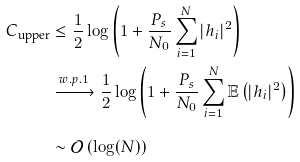Convert formula to latex. <formula><loc_0><loc_0><loc_500><loc_500>C _ { \text {upper} } & \leq \frac { 1 } { 2 } \log \left ( 1 + \frac { P _ { s } } { N _ { 0 } } \sum _ { i = 1 } ^ { N } | h _ { i } | ^ { 2 } \right ) \\ & \xrightarrow { w . p . 1 } \frac { 1 } { 2 } \log \left ( 1 + \frac { P _ { s } } { N _ { 0 } } \sum _ { i = 1 } ^ { N } \mathbb { E } \left ( | h _ { i } | ^ { 2 } \right ) \right ) \\ & \sim \mathcal { O } \left ( \log ( N ) \right )</formula> 